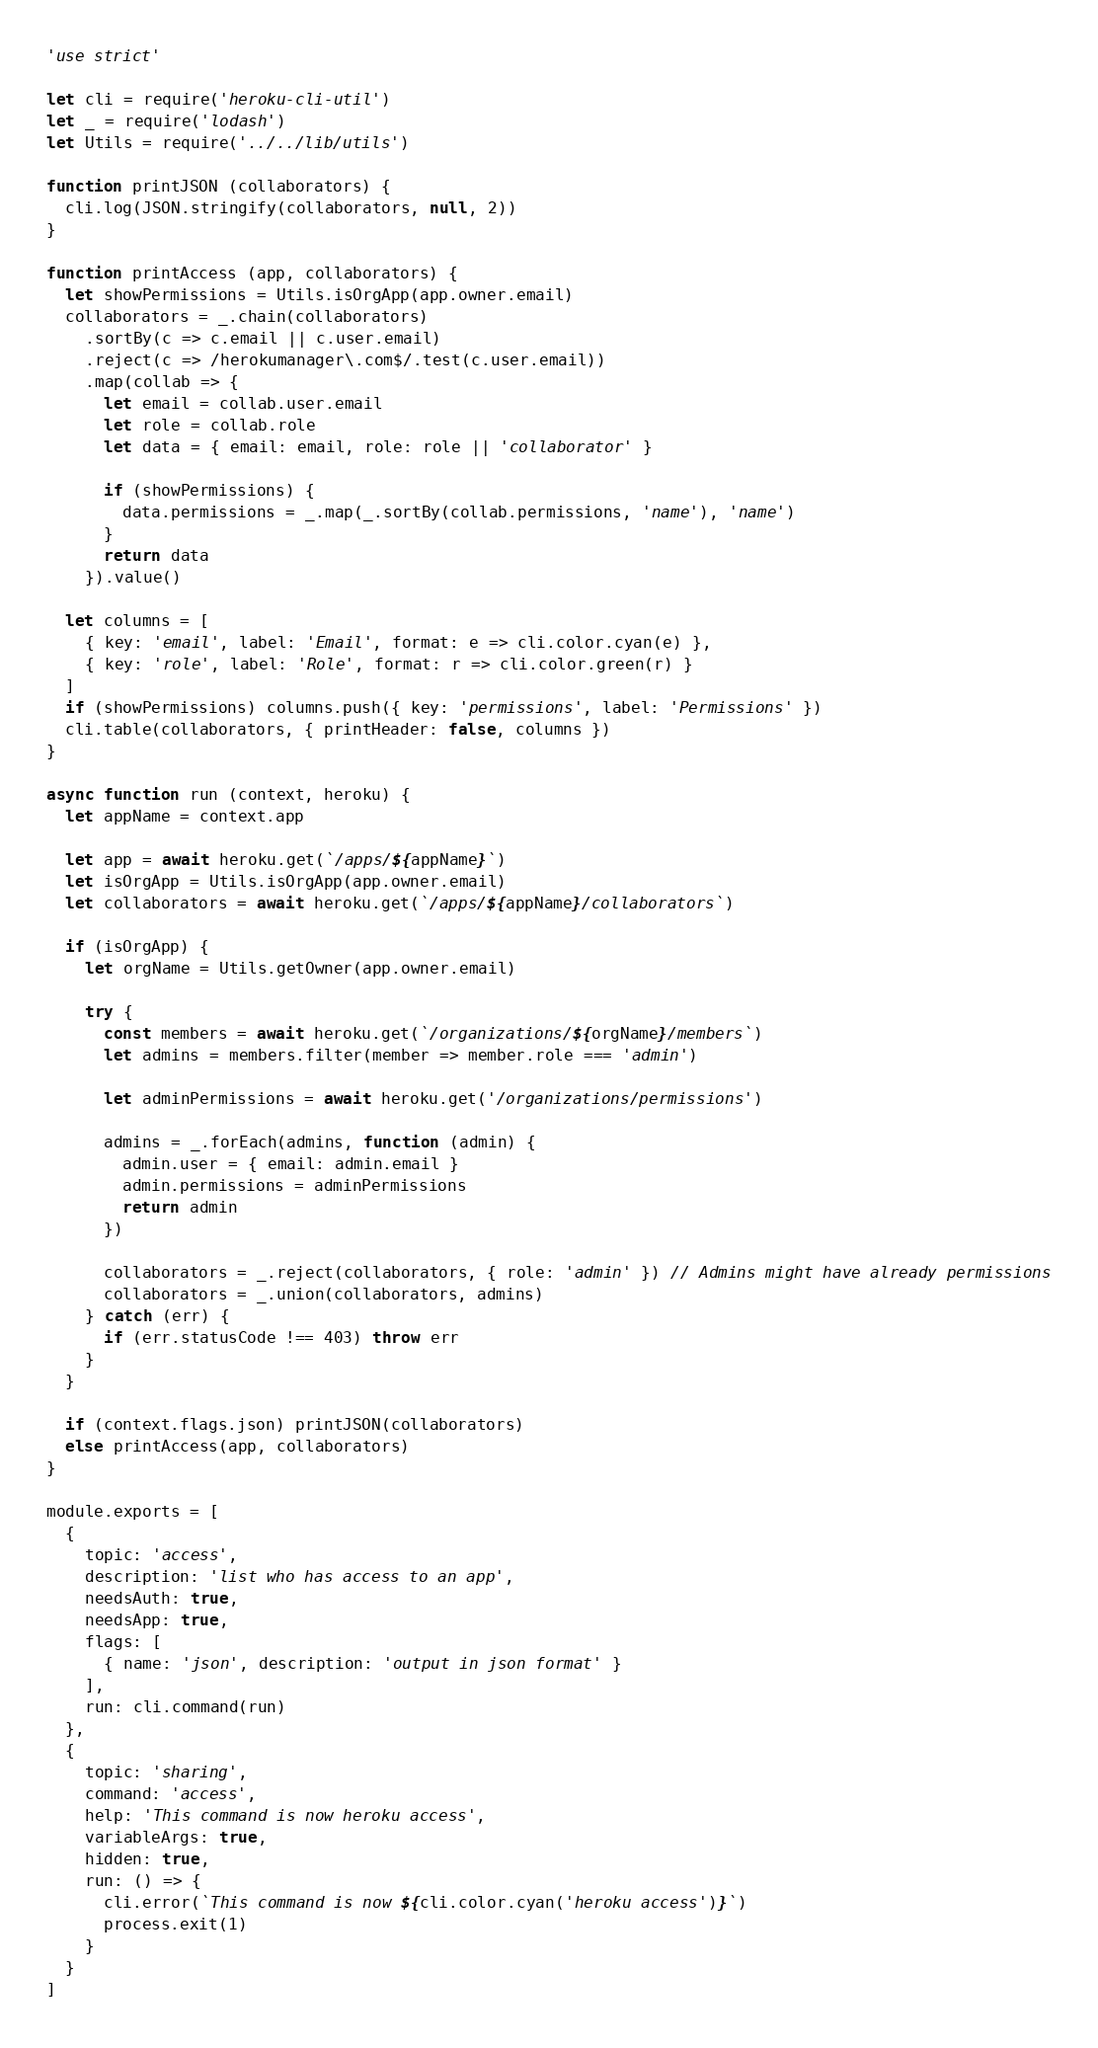Convert code to text. <code><loc_0><loc_0><loc_500><loc_500><_JavaScript_>'use strict'

let cli = require('heroku-cli-util')
let _ = require('lodash')
let Utils = require('../../lib/utils')

function printJSON (collaborators) {
  cli.log(JSON.stringify(collaborators, null, 2))
}

function printAccess (app, collaborators) {
  let showPermissions = Utils.isOrgApp(app.owner.email)
  collaborators = _.chain(collaborators)
    .sortBy(c => c.email || c.user.email)
    .reject(c => /herokumanager\.com$/.test(c.user.email))
    .map(collab => {
      let email = collab.user.email
      let role = collab.role
      let data = { email: email, role: role || 'collaborator' }

      if (showPermissions) {
        data.permissions = _.map(_.sortBy(collab.permissions, 'name'), 'name')
      }
      return data
    }).value()

  let columns = [
    { key: 'email', label: 'Email', format: e => cli.color.cyan(e) },
    { key: 'role', label: 'Role', format: r => cli.color.green(r) }
  ]
  if (showPermissions) columns.push({ key: 'permissions', label: 'Permissions' })
  cli.table(collaborators, { printHeader: false, columns })
}

async function run (context, heroku) {
  let appName = context.app

  let app = await heroku.get(`/apps/${appName}`)
  let isOrgApp = Utils.isOrgApp(app.owner.email)
  let collaborators = await heroku.get(`/apps/${appName}/collaborators`)

  if (isOrgApp) {
    let orgName = Utils.getOwner(app.owner.email)

    try {
      const members = await heroku.get(`/organizations/${orgName}/members`)
      let admins = members.filter(member => member.role === 'admin')

      let adminPermissions = await heroku.get('/organizations/permissions')

      admins = _.forEach(admins, function (admin) {
        admin.user = { email: admin.email }
        admin.permissions = adminPermissions
        return admin
      })

      collaborators = _.reject(collaborators, { role: 'admin' }) // Admins might have already permissions
      collaborators = _.union(collaborators, admins)
    } catch (err) {
      if (err.statusCode !== 403) throw err
    }
  }

  if (context.flags.json) printJSON(collaborators)
  else printAccess(app, collaborators)
}

module.exports = [
  {
    topic: 'access',
    description: 'list who has access to an app',
    needsAuth: true,
    needsApp: true,
    flags: [
      { name: 'json', description: 'output in json format' }
    ],
    run: cli.command(run)
  },
  {
    topic: 'sharing',
    command: 'access',
    help: 'This command is now heroku access',
    variableArgs: true,
    hidden: true,
    run: () => {
      cli.error(`This command is now ${cli.color.cyan('heroku access')}`)
      process.exit(1)
    }
  }
]
</code> 